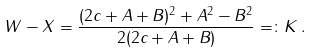<formula> <loc_0><loc_0><loc_500><loc_500>W - X = \frac { ( 2 c + A + B ) ^ { 2 } + A ^ { 2 } - B ^ { 2 } } { 2 ( 2 c + A + B ) } = \colon K \, .</formula> 